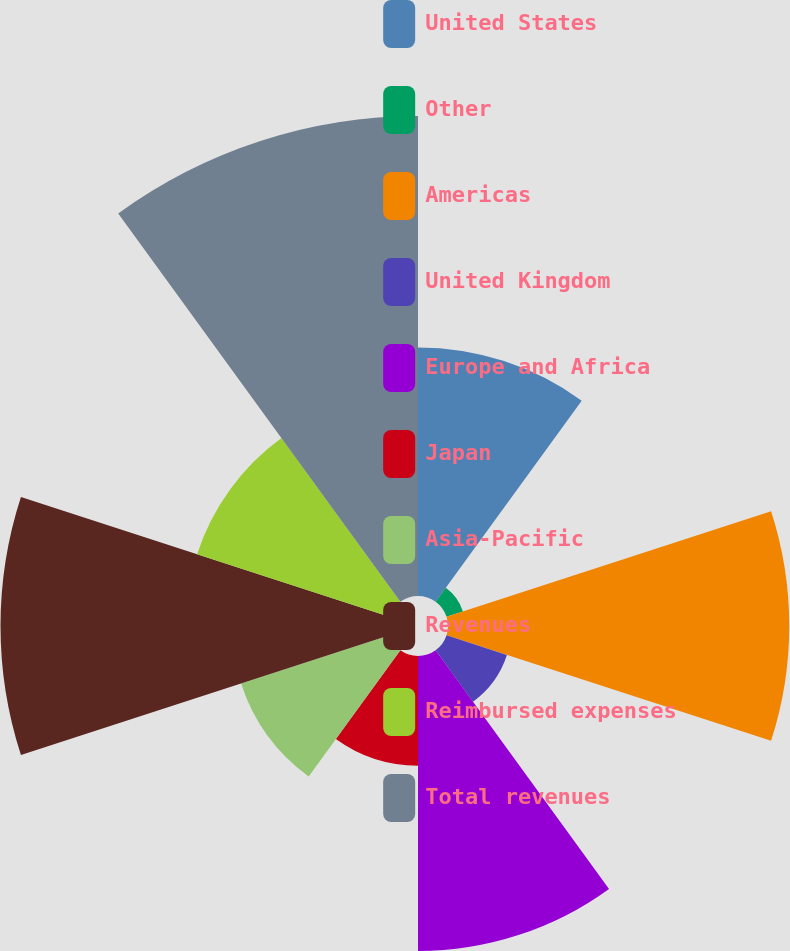Convert chart. <chart><loc_0><loc_0><loc_500><loc_500><pie_chart><fcel>United States<fcel>Other<fcel>Americas<fcel>United Kingdom<fcel>Europe and Africa<fcel>Japan<fcel>Asia-Pacific<fcel>Revenues<fcel>Reimbursed expenses<fcel>Total revenues<nl><fcel>10.8%<fcel>0.75%<fcel>14.83%<fcel>2.76%<fcel>12.82%<fcel>4.77%<fcel>6.78%<fcel>16.84%<fcel>8.79%<fcel>20.86%<nl></chart> 